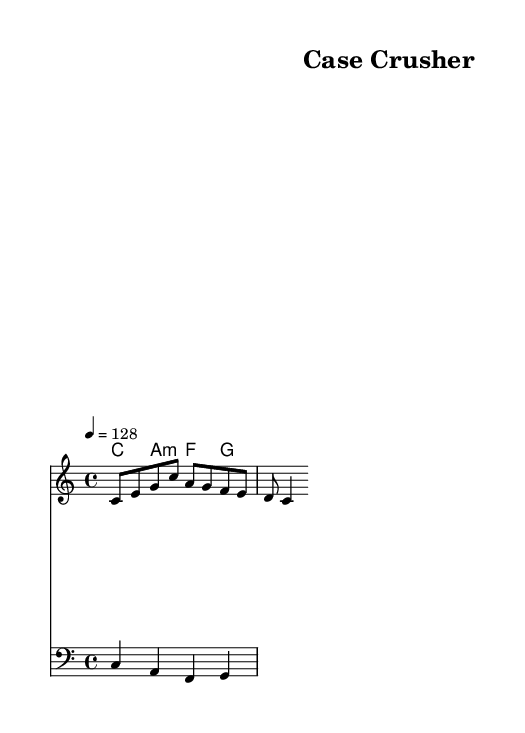What is the key signature of this music? The key signature is C major, which has no sharps or flats indicated on the staff.
Answer: C major What is the time signature of this music? The time signature is 4/4, as shown at the beginning of the score, meaning there are four beats per measure.
Answer: 4/4 What is the tempo marking for this piece? The tempo marking indicates a speed of quarter note equals 128 beats per minute, which is an upbeat tempo suitable for high-energy tracks.
Answer: 128 Which chords are used in the harmonies? The chords indicated in the harmonies section are C major, A minor, F major, and G major, as specified underneath the melody staff.
Answer: C, A minor, F, G How many measures are in the melody? The melody section consists of one measure's worth of notes and rests, as counted directly from the melody line.
Answer: 1 What is the highest note in the melody? The highest note in the melody is C, which appears prominently among the other notes and is the first note of the melody.
Answer: C Which clef is used in the bass staff? The bass staff is indicated using the bass clef, which is designed to accommodate lower pitches.
Answer: Bass clef 